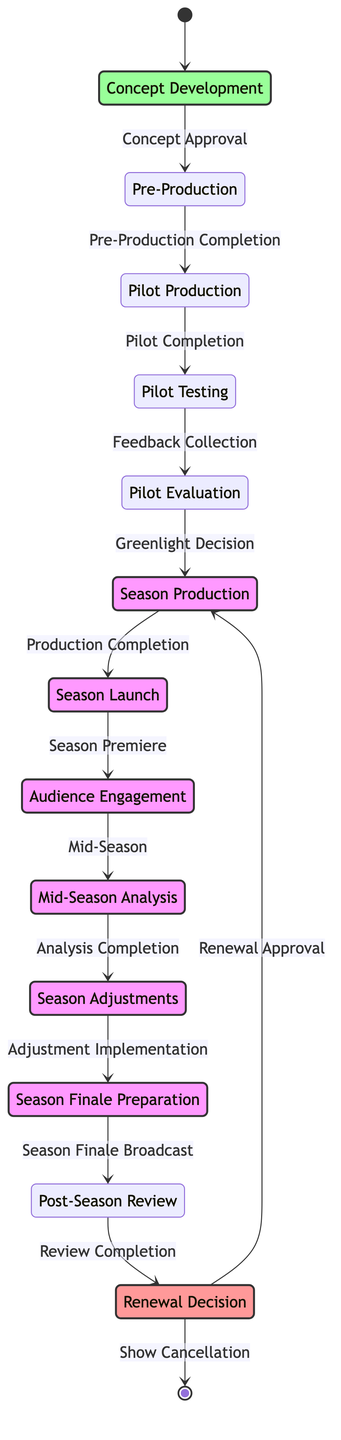What is the initial state of the diagram? The diagram starts at the "Concept Development" state, where the process begins. This information can be directly seen from the diagram's start symbol, which points to "Concept Development."
Answer: Concept Development How many main states are there in the diagram? The diagram presents a total of 13 states, which are indicated as nodes in the diagram. By counting each labeled state in the visual representation, we reach this total.
Answer: 13 What is the last state before a potential show cancellation? The last state before the option for cancellation is "Renewal Decision," which follows all review processes and leads to the decision about the show's future. This is evident from the final transition connecting the process to the end.
Answer: Renewal Decision What triggers the transition from "Pilot Evaluation" to "Season Production"? The transition is triggered by the "Greenlight Decision," which indicates that the show has received approval to move into production for the season after evaluating the pilot. This can be seen in the labeled arrow linking these two states.
Answer: Greenlight Decision Which state involves analyzing viewer ratings? "Mid-Season Analysis" is dedicated to reviewing audience ratings and engagement metrics, as indicated in the description of that specific state within the diagram.
Answer: Mid-Season Analysis What happens after "Audience Engagement"? After "Audience Engagement," the next state in the flow is "Mid-Season Analysis," which indicates a systematic review takes place after engaging with the audience. This is shown by the transition leading directly from one to the other.
Answer: Mid-Season Analysis How many transitions are there in the diagram? There are 12 transitions connecting the various states, as each arrow represents a transition between states, and can be counted in the diagram.
Answer: 12 What is the state where marketing efforts for the season finale occur? "Season Finale Preparation" is designated for marketing and promoting the season finale to maximize viewership during this critical phase, as specified in the diagram's description of this state.
Answer: Season Finale Preparation What is the final action taken after the "Post-Season Review"? The final action taken is determining the "Renewal Decision," which indicates whether the show will return for another season or not. This progression is clear from the transition leading from "Post-Season Review" to "Renewal Decision."
Answer: Renewal Decision 